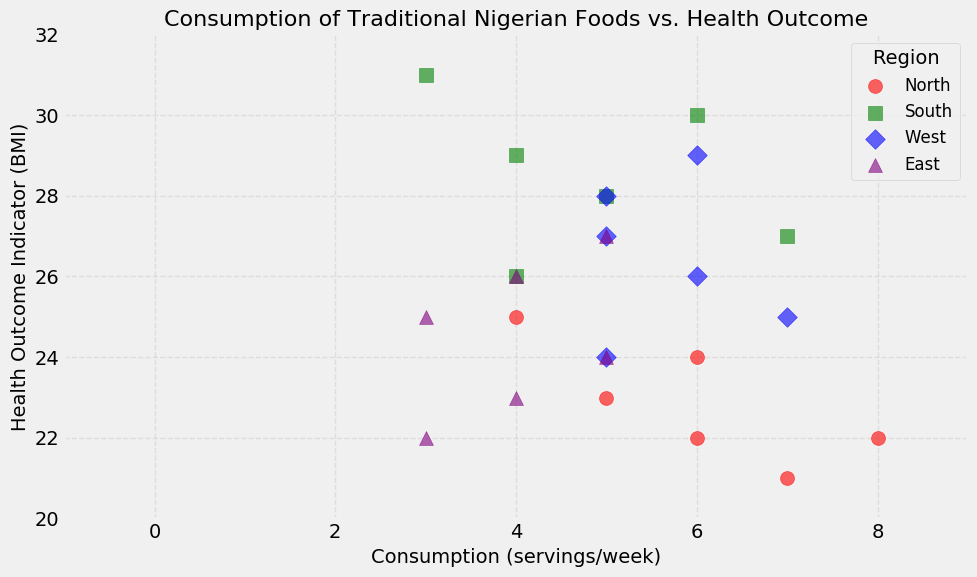What region has the highest average BMI among all regions? To determine the region with the highest average BMI, we first calculate the average BMI for each region. North: (22 + 24 + 21 + 23 + 25 + 22)/6 = 22.83; South: (28 + 30 + 27 + 29 + 31 + 26)/6 = 28.5; West: (26 + 28 + 25 + 27 + 29 + 24)/6 = 26.5; East: (23 + 24 + 22 + 26 + 27 + 25)/6 = 24.5. Comparing these values, the highest average BMI is in the South.
Answer: South Compare the consumption of traditional foods in the North and South regions. Which region consumes more per week on average? To compare, calculate the average consumption for North: (8 + 6 + 7 + 5 + 4 + 6)/6 = 6; South: (5 + 6 + 7 + 4 + 3 + 4)/6 = 4.83. The North region consumes more servings per week on average.
Answer: North Which traditional food has the highest BMI associated with its consumption in the South region? By examining the scatter plot and focusing on the South region, we look at the foods: Amala (5:28, 6:30, 7:27) and Efo Riro (4:29, 3:31, 4:26). Efo Riro at 3 servings/week has an associated BMI of 31, which is the highest among the South region's foods.
Answer: Efo Riro What is the range of the health outcome indicator (BMI) for the West region? To find the range, identify the minimum and maximum BMI values for the West region. The BMIs are 24, 25, 26, 27, 28, 29. The range is calculated as maximum - minimum, which is 29 - 24 = 5.
Answer: 5 Is there any food in the graph that has a perfect linear relationship between consumption and BMI? A perfect linear relationship would show all points in a straight line. Upon quick inspection, there is no food where BMI consistently increases or decreases in a straight line with increased consumption. Thus, no food exhibits a perfect linear relationship.
Answer: No How does the consumption of Jollof Rice correlate with BMI in the West region? To determine the correlation, we examine Jollof Rice in the West, focusing on the points (6,26), (5,28), and (7,25). The BMIs slightly vary as consumption goes up and down, indicating a weak negative correlation where BMI does not change drastically with consumption.
Answer: Weak negative correlation Which region shows the most diverse range of BMI values for their food consumption? To assess range diversity, compare the BMI ranges per region: North (21-25), South (26-31), West (24-29), East (22-27). The South region has the widest range (5 units), showing the most diversity in BMI values for their food consumption.
Answer: South Does higher consumption in the North correlate with lower or higher BMI? Observing the North's scatter points for Tuwo Shinkafa and Miyan Kuka, a rough pattern suggests that higher consumption does not consistently correlate with higher or lower BMI. There is no clear trend either way.
Answer: No clear correlation 